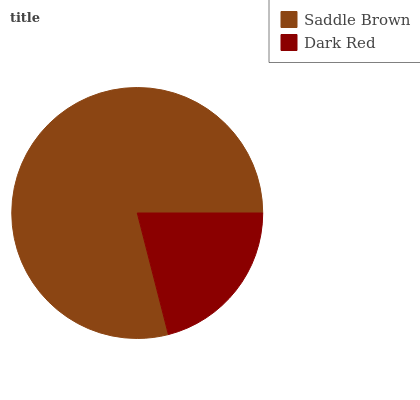Is Dark Red the minimum?
Answer yes or no. Yes. Is Saddle Brown the maximum?
Answer yes or no. Yes. Is Dark Red the maximum?
Answer yes or no. No. Is Saddle Brown greater than Dark Red?
Answer yes or no. Yes. Is Dark Red less than Saddle Brown?
Answer yes or no. Yes. Is Dark Red greater than Saddle Brown?
Answer yes or no. No. Is Saddle Brown less than Dark Red?
Answer yes or no. No. Is Saddle Brown the high median?
Answer yes or no. Yes. Is Dark Red the low median?
Answer yes or no. Yes. Is Dark Red the high median?
Answer yes or no. No. Is Saddle Brown the low median?
Answer yes or no. No. 